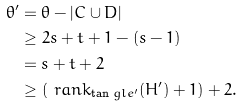Convert formula to latex. <formula><loc_0><loc_0><loc_500><loc_500>\theta ^ { \prime } & = \theta - | C \cup D | \\ & \geq 2 s + t + 1 - ( s - 1 ) \\ & = s + t + 2 \\ & \geq ( \ r a n k _ { \tan g l e ^ { \prime } } ( H ^ { \prime } ) + 1 ) + 2 .</formula> 